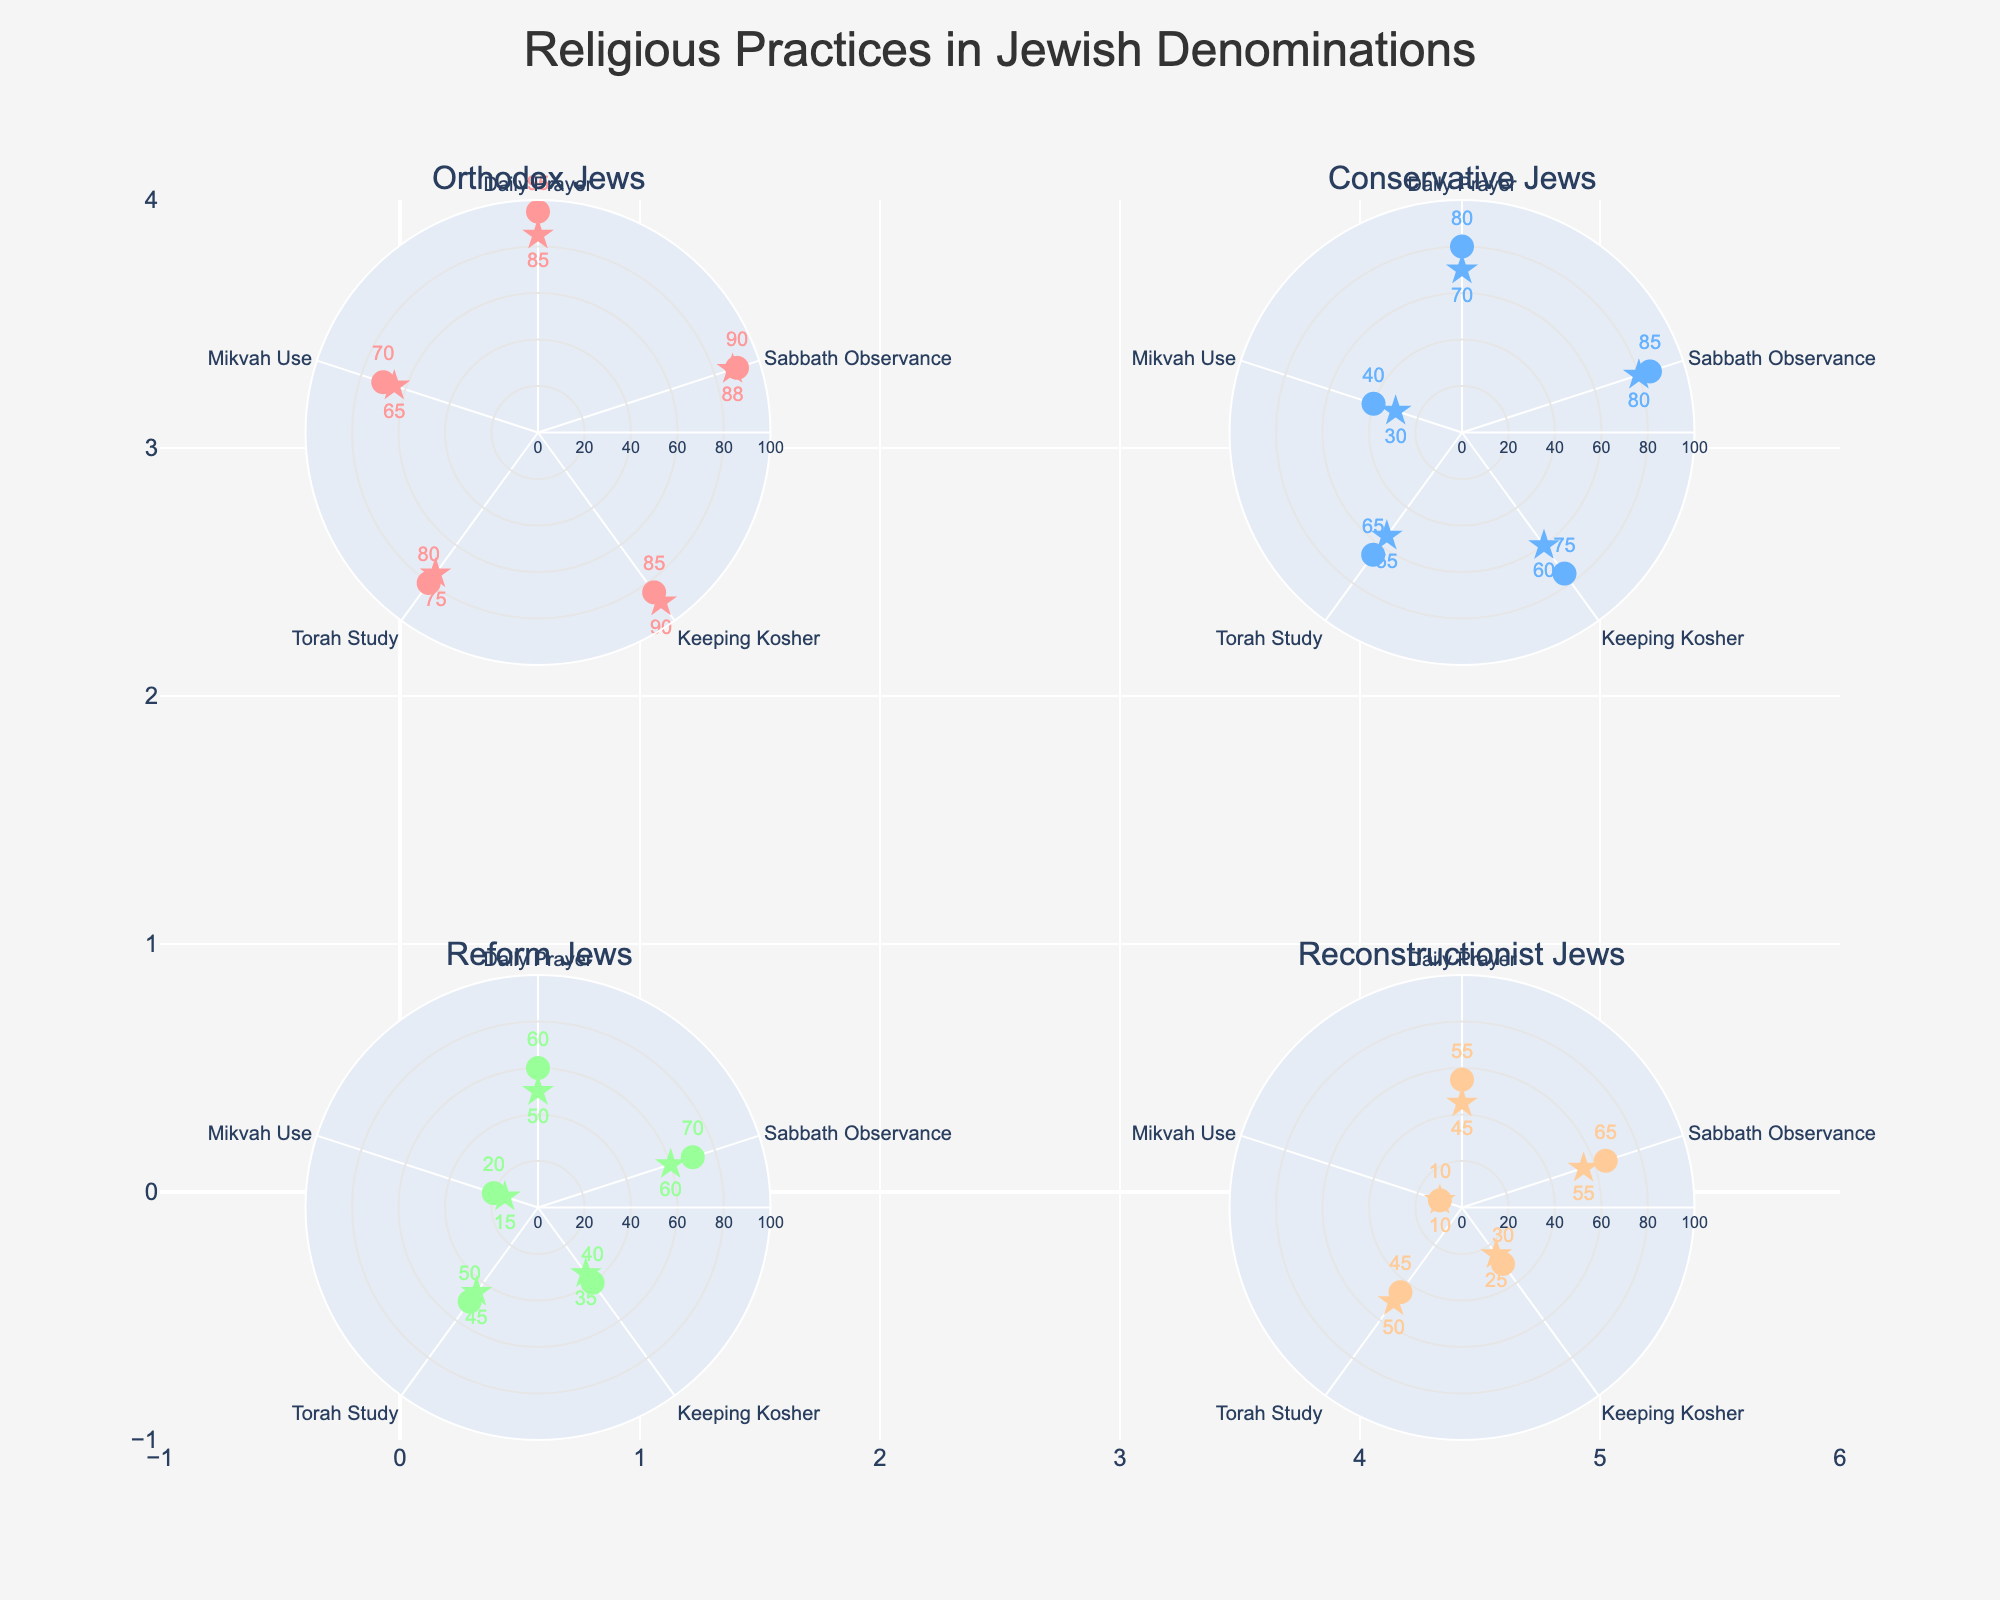What is the frequency of Daily Prayer among Orthodox Jews? Look for the marker labeled "Daily Prayer" in the Orthodox Jews subplot and read the frequency value shown near the marker.
Answer: 95 Which denomination has the lowest popularity for Mikvah Use? Refer to each subplot for Mikvah Use's popularity. Orthodox, Conservative, Reform, and Reconstructionist have values of 65, 30, 15, and 10, respectively.
Answer: Reconstructionist What is the highest frequency value for Keeping Kosher, and which denomination does it belong to? Compare the frequency values of Keeping Kosher across all denominations. The values are 85 (Orthodox), 75 (Conservative), 40 (Reform), and 30 (Reconstructionist).
Answer: 85, Orthodox How does the frequency of Torah Study compare between Conservative and Reform Jews? Compare the frequency values for Torah Study for Conservative (65) and Reform (50) Jews in the respective subplots.
Answer: Conservative Jews have a higher frequency What's the combined popularity of Sabbath Observance across all denominations? Add up the popularity figures for Sabbath Observance: 88 (Orthodox) + 80 (Conservative) + 60 (Reform) + 55 (Reconstructionist) = 283.
Answer: 283 Which practice is least popular among Orthodox Jews? Observe the popularity values for all practices among Orthodox Jews. The lowest value is 65 for Mikvah Use.
Answer: Mikvah Use What is the difference in frequency between Daily Prayer and Mikvah Use in Reform Jews? Subtract the frequency of Mikvah Use (20) from that of Daily Prayer (60) among Reform Jews: 60 - 20 = 40.
Answer: 40 What practice has the highest overall frequency when including all denominations? Look at the highest frequency values for all practices across all denominations. Daily Prayer (Orthodox, 95) has the highest frequency.
Answer: Daily Prayer Which denomination shows the highest discrepancy between frequency and popularity for Keeping Kosher? Calculate the absolute difference between frequency and popularity for Keeping Kosher across all denominations: Orthodox (85-90=5), Conservative (75-60=15), Reform (40-35=5), Reconstructionist (30-25=5).
Answer: Conservative How does the popularity of Torah Study in Reconstructionist Jews compare to its frequency? Compare the popularity (50) and frequency (45) of Torah Study in the Reconstructionist subplot. The popularity is higher.
Answer: Popularity is higher 